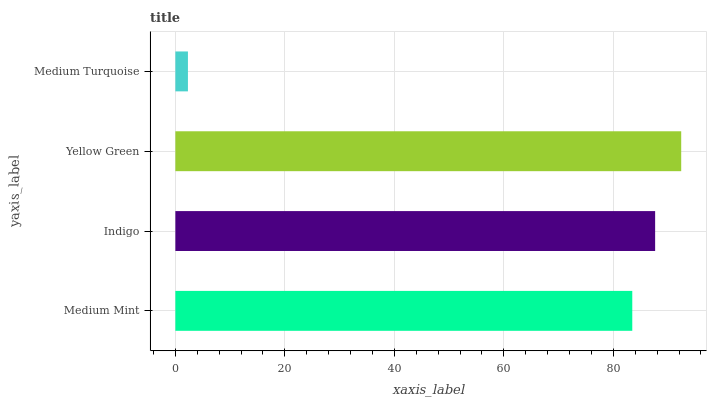Is Medium Turquoise the minimum?
Answer yes or no. Yes. Is Yellow Green the maximum?
Answer yes or no. Yes. Is Indigo the minimum?
Answer yes or no. No. Is Indigo the maximum?
Answer yes or no. No. Is Indigo greater than Medium Mint?
Answer yes or no. Yes. Is Medium Mint less than Indigo?
Answer yes or no. Yes. Is Medium Mint greater than Indigo?
Answer yes or no. No. Is Indigo less than Medium Mint?
Answer yes or no. No. Is Indigo the high median?
Answer yes or no. Yes. Is Medium Mint the low median?
Answer yes or no. Yes. Is Medium Mint the high median?
Answer yes or no. No. Is Medium Turquoise the low median?
Answer yes or no. No. 